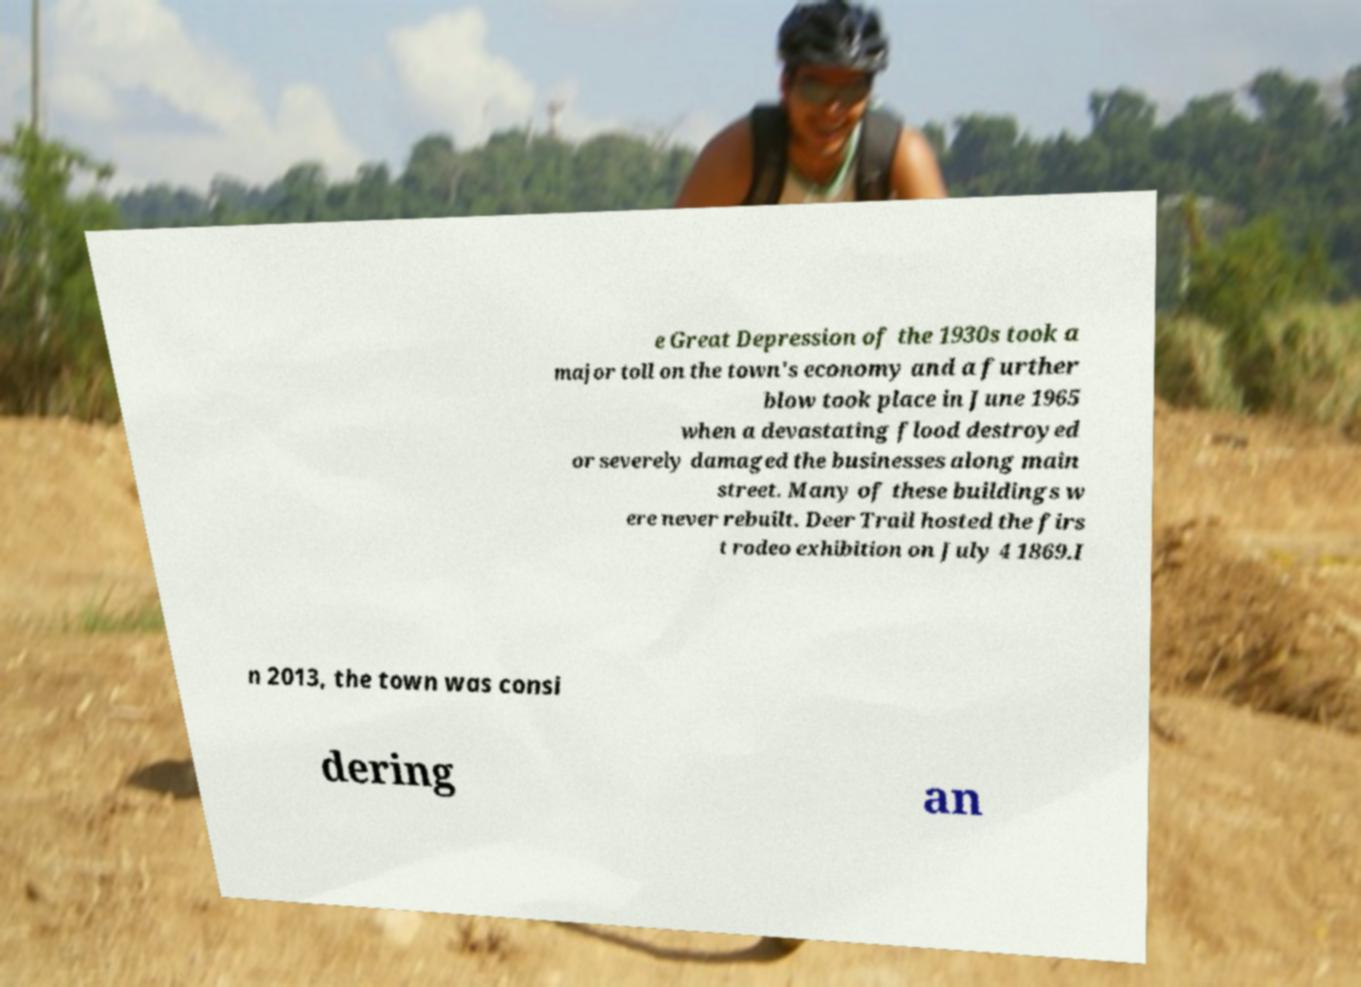There's text embedded in this image that I need extracted. Can you transcribe it verbatim? e Great Depression of the 1930s took a major toll on the town's economy and a further blow took place in June 1965 when a devastating flood destroyed or severely damaged the businesses along main street. Many of these buildings w ere never rebuilt. Deer Trail hosted the firs t rodeo exhibition on July 4 1869.I n 2013, the town was consi dering an 